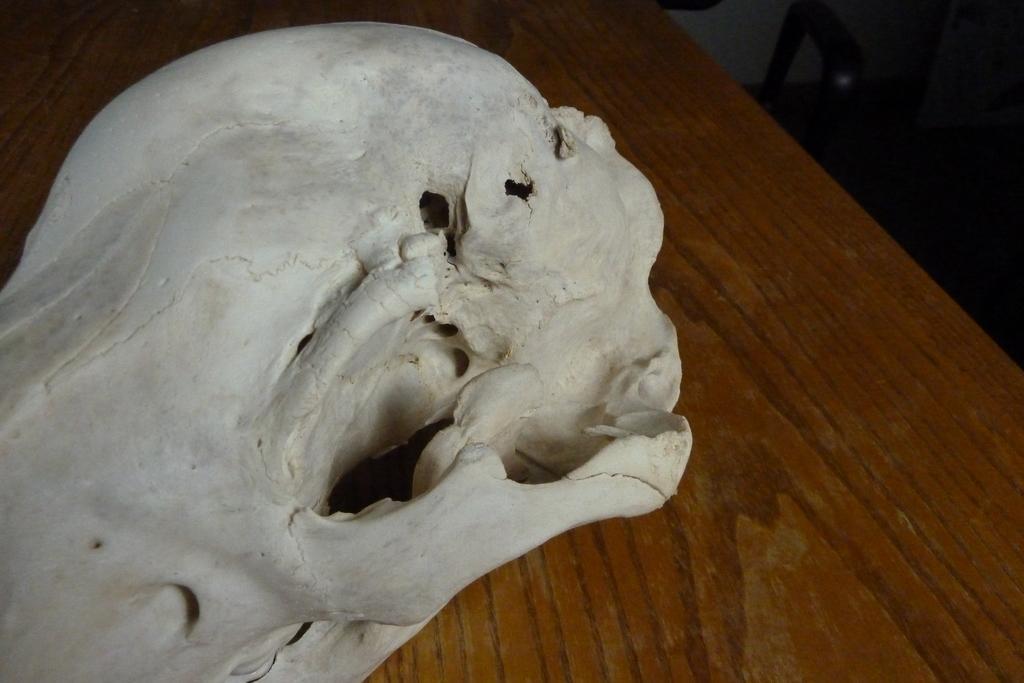Describe this image in one or two sentences. In this image I can see a skull on a table. In the top right-hand corner there are few objects in the dark. 